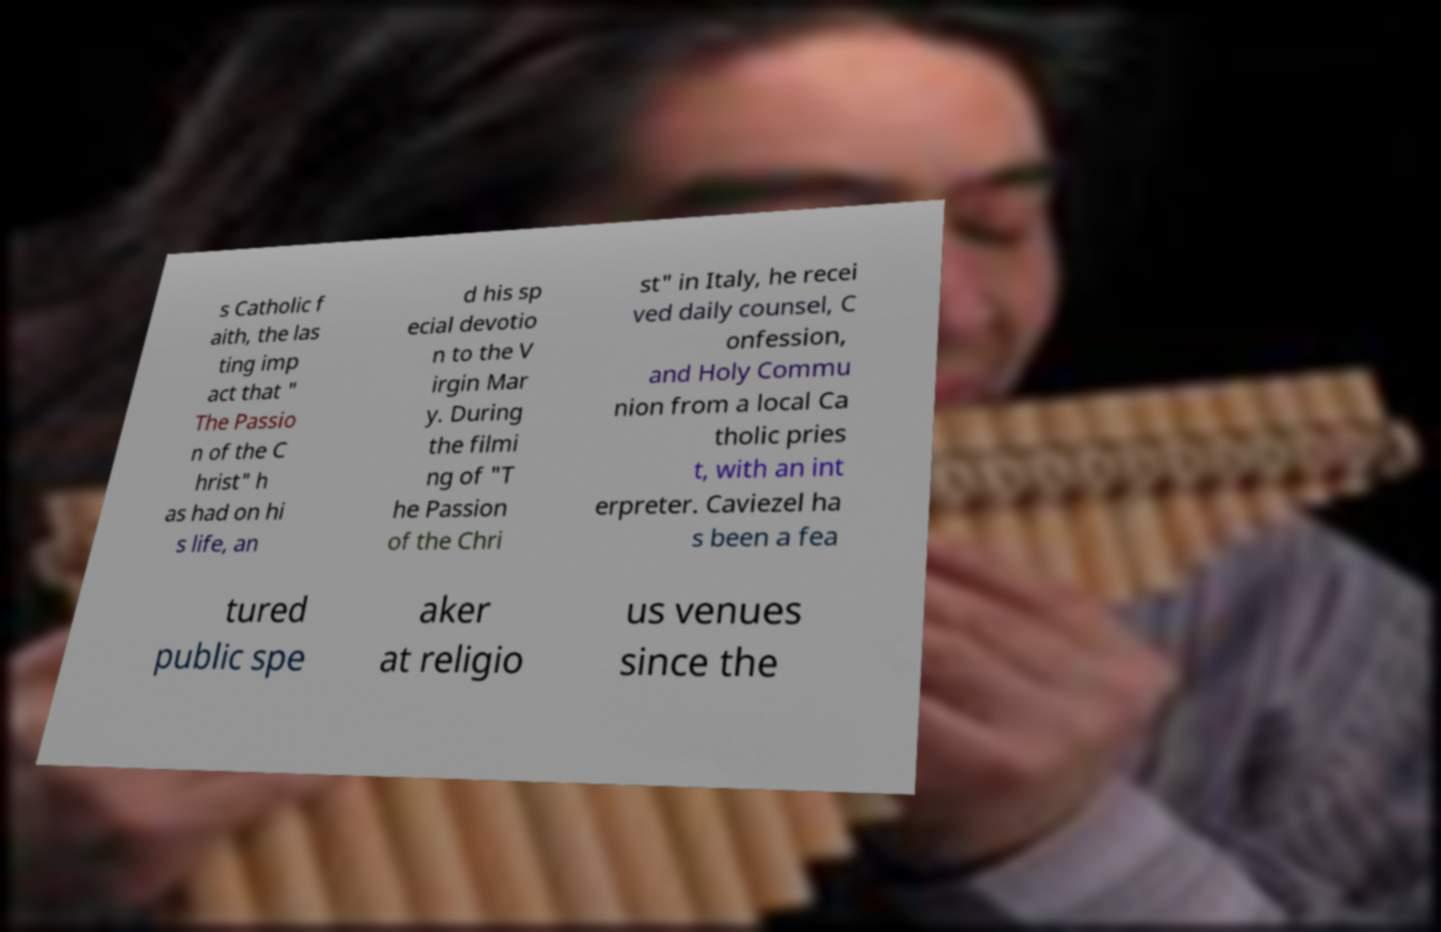Can you read and provide the text displayed in the image?This photo seems to have some interesting text. Can you extract and type it out for me? s Catholic f aith, the las ting imp act that " The Passio n of the C hrist" h as had on hi s life, an d his sp ecial devotio n to the V irgin Mar y. During the filmi ng of "T he Passion of the Chri st" in Italy, he recei ved daily counsel, C onfession, and Holy Commu nion from a local Ca tholic pries t, with an int erpreter. Caviezel ha s been a fea tured public spe aker at religio us venues since the 